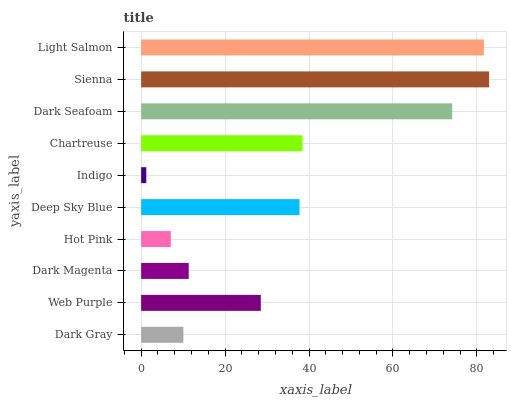Is Indigo the minimum?
Answer yes or no. Yes. Is Sienna the maximum?
Answer yes or no. Yes. Is Web Purple the minimum?
Answer yes or no. No. Is Web Purple the maximum?
Answer yes or no. No. Is Web Purple greater than Dark Gray?
Answer yes or no. Yes. Is Dark Gray less than Web Purple?
Answer yes or no. Yes. Is Dark Gray greater than Web Purple?
Answer yes or no. No. Is Web Purple less than Dark Gray?
Answer yes or no. No. Is Deep Sky Blue the high median?
Answer yes or no. Yes. Is Web Purple the low median?
Answer yes or no. Yes. Is Chartreuse the high median?
Answer yes or no. No. Is Dark Seafoam the low median?
Answer yes or no. No. 